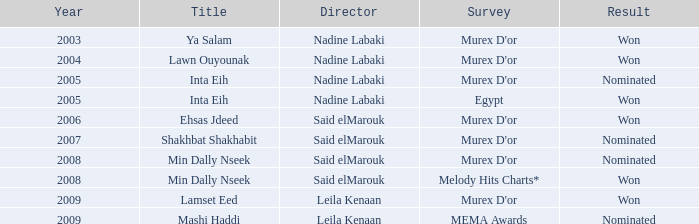Which director, with the min dally nseek title, emerged victorious? Said elMarouk. 